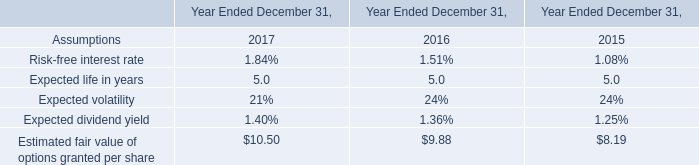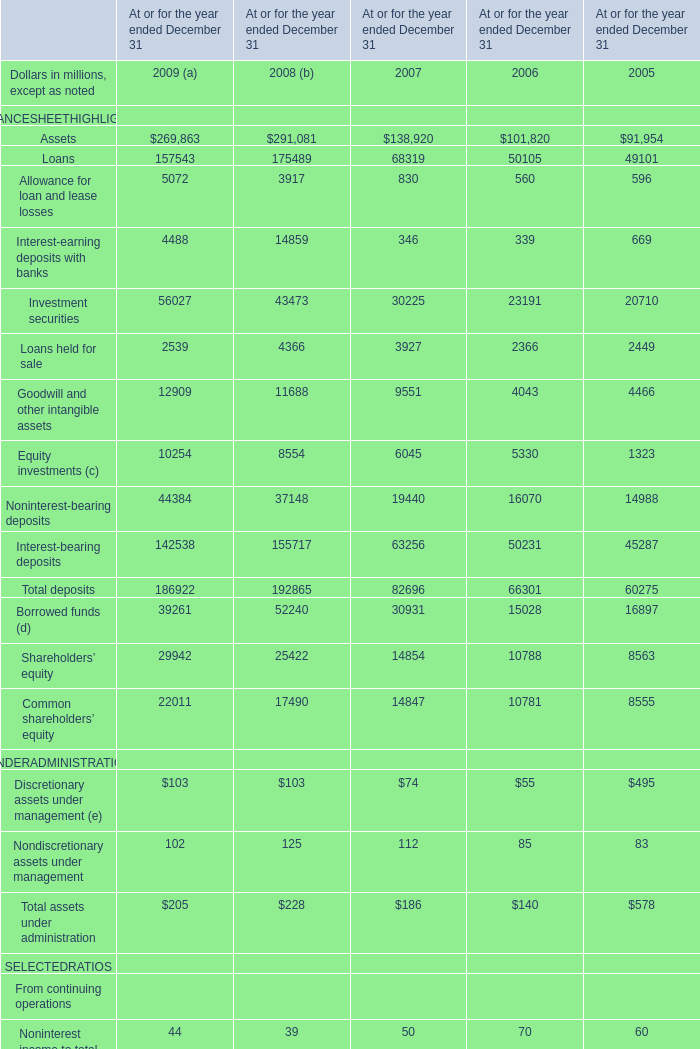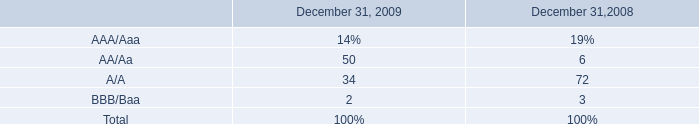if there were 50 facilities being rated in 2009 , how many were bbb/baa? 
Computations: ((100 / 50) / (100 / 50))
Answer: 1.0. 